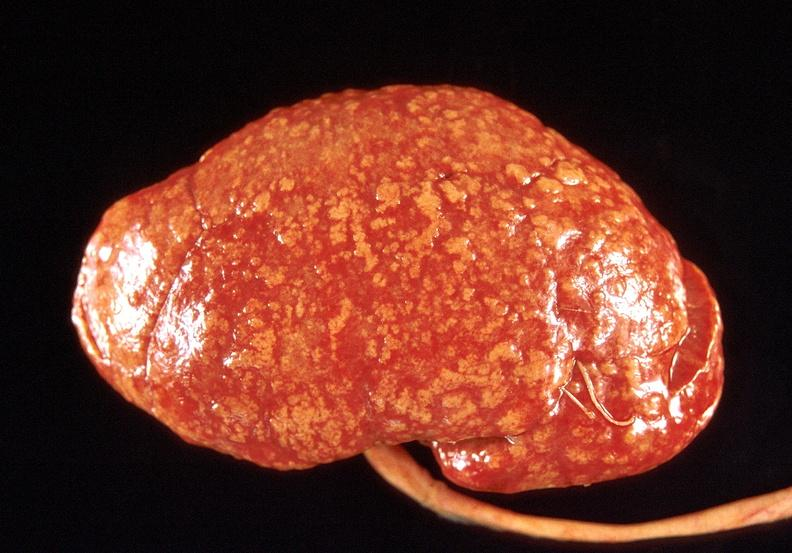what does this image show?
Answer the question using a single word or phrase. Kidney 